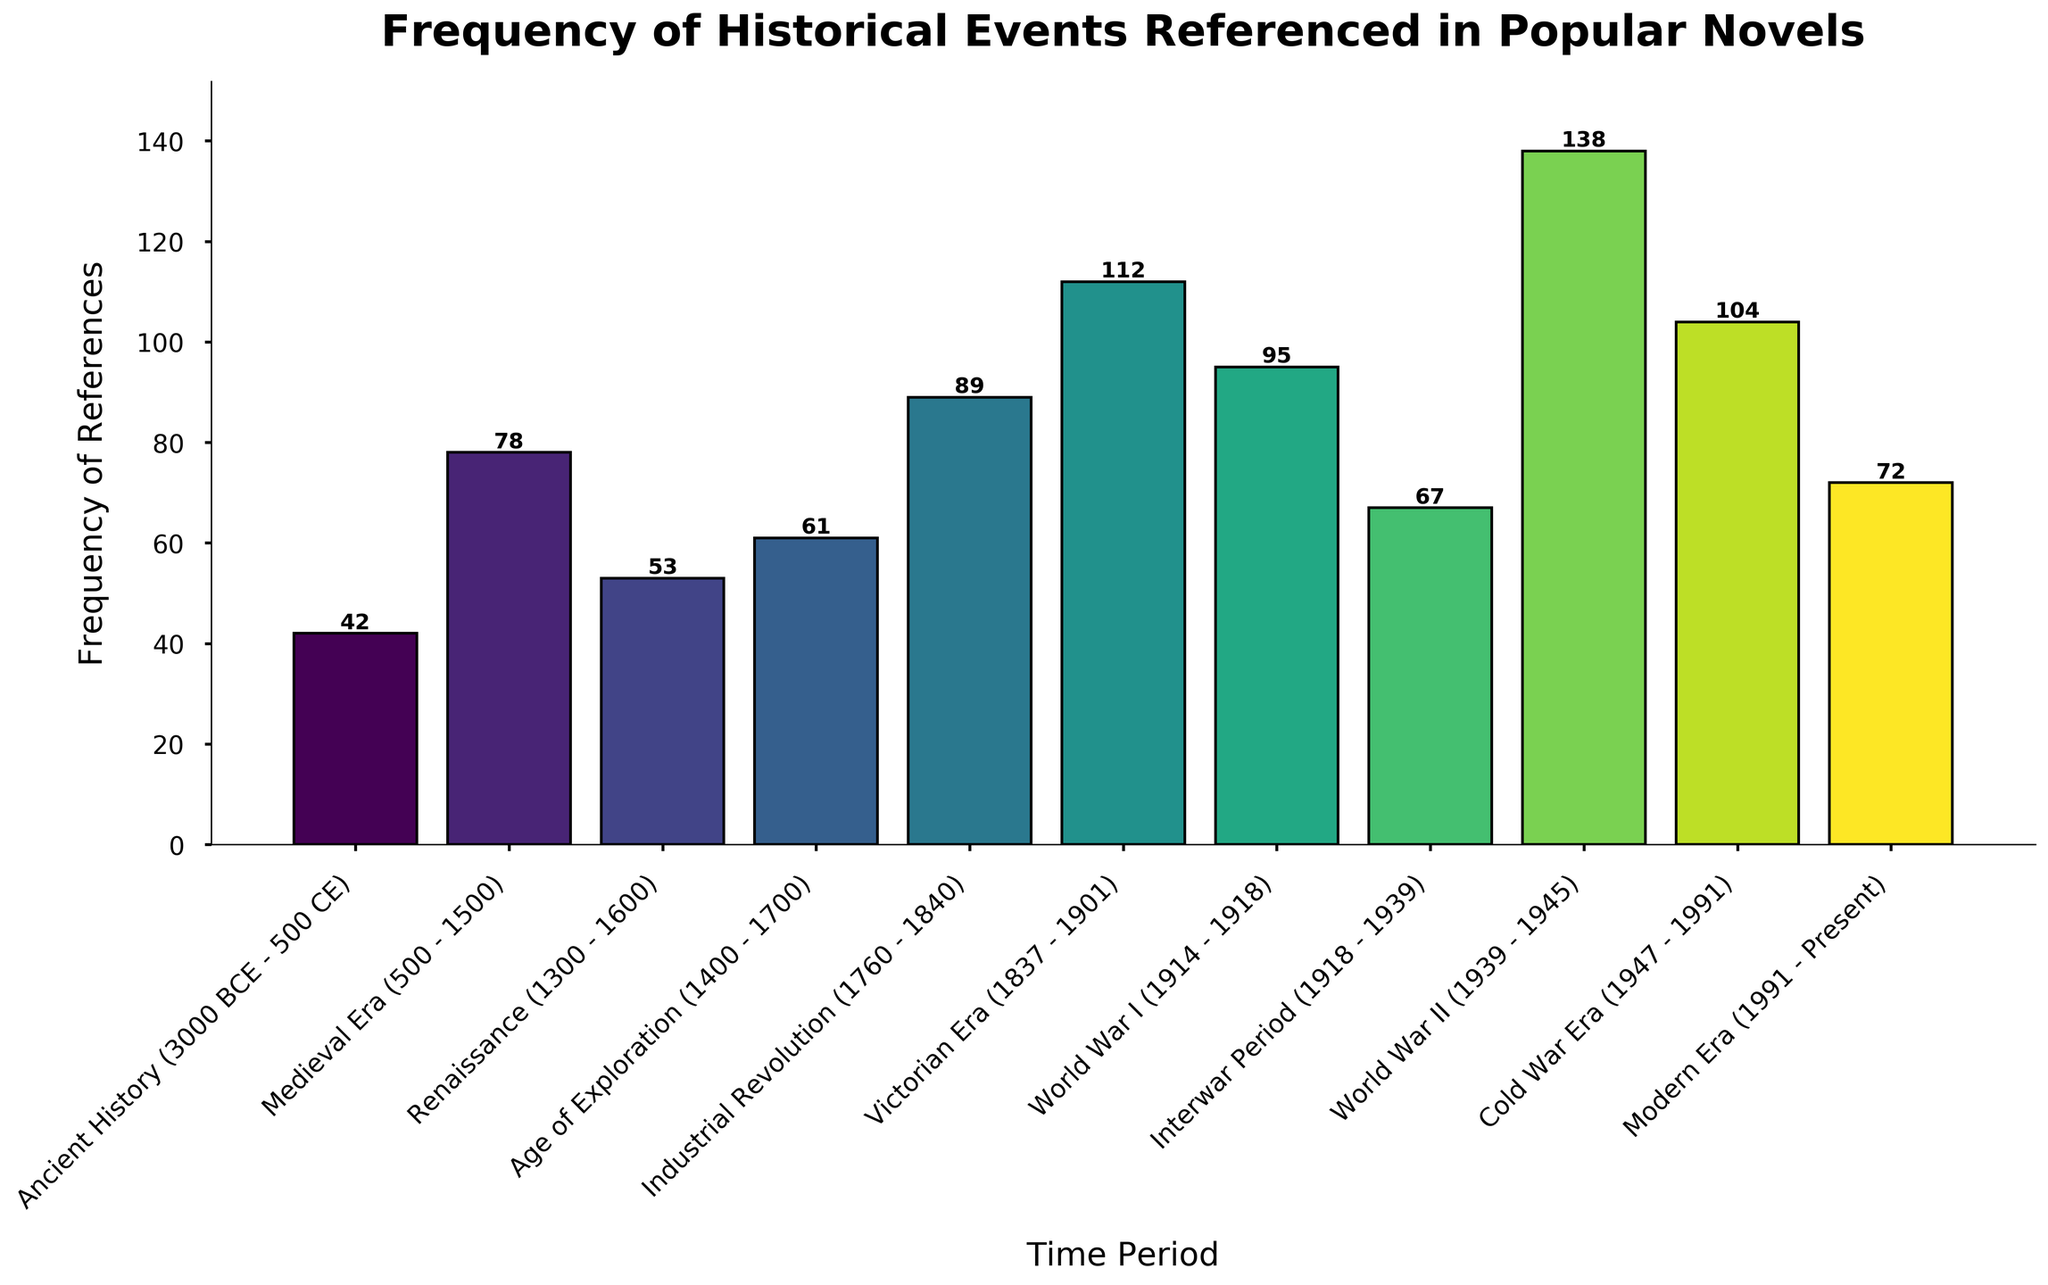Which time period has the highest number of historical references? We need to identify the bar with the greatest height in the plot. The tallest bar represents "World War II" with a frequency of 138.
Answer: World War II Which era has fewer historical references: the Age of Exploration or the Interwar Period? Compare the heights of the bars for the Age of Exploration and the Interwar Period. The Age of Exploration has 61 references, while the Interwar Period has 67 references, making the Interwar Period slightly higher.
Answer: Age of Exploration What is the difference in the number of references between the Victorian Era and World War I? Subtract the frequency of World War I from the frequency of the Victorian Era. Victorian Era has 112 references, and World War I has 95 references. The difference is 112 - 95 = 17.
Answer: 17 How many historical references are there in total for the Ancient History, Medieval Era, and Renaissance periods combined? Add the frequencies of Ancient History, Medieval Era, and Renaissance. 42 (Ancient History) + 78 (Medieval Era) + 53 (Renaissance) = 173.
Answer: 173 Is the frequency of historical references in the Cold War Era greater than in the Modern Era? Compare the heights of the bars for the Cold War Era and the Modern Era. The Cold War Era has 104 references compared to 72 in the Modern Era, so the Cold War Era is greater.
Answer: Yes What is the average number of references across all time periods? Sum all the frequency values and divide by the number of periods. (42 + 78 + 53 + 61 + 89 + 112 + 95 + 67 + 138 + 104 + 72) / 11 = 911 / 11 = 82.82.
Answer: 82.82 Which two consecutive periods have the largest increase in historical references? Calculate the difference in frequencies between each pair of consecutive periods and find the largest one. The increase from the Industrial Revolution (89) to the Victorian Era (112) is 112 - 89 = 23. All other consecutive differences are smaller.
Answer: Industrial Revolution to Victorian Era Which period has the lowest number of historical references, and what is that number? Identify the bar with the smallest height. The Ancient History period has the lowest number of references with a frequency of 42.
Answer: Ancient History If you add the frequencies of World War I and World War II, what is the sum? Add the frequencies of the World War I and World War II periods. 95 (World War I) + 138 (World War II) = 233.
Answer: 233 